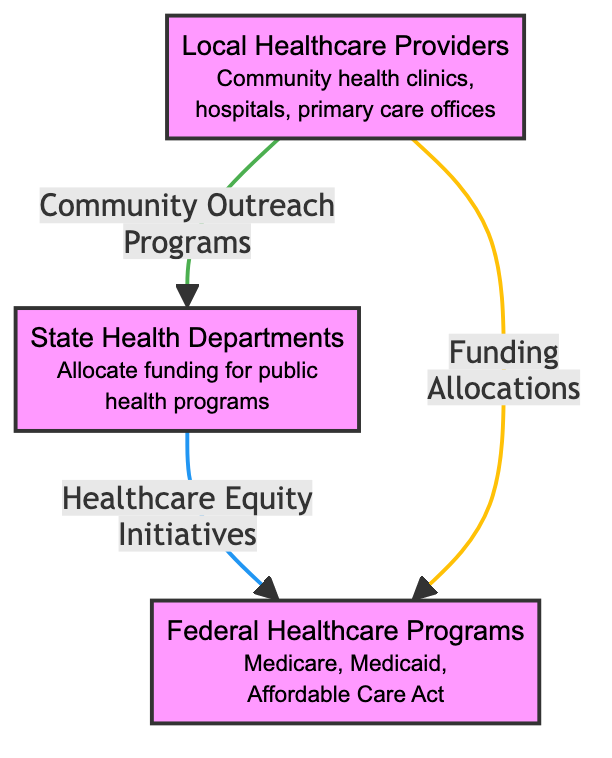What are the three nodes in the diagram? The diagram features three nodes: Local Healthcare Providers, State Health Departments, and Federal Healthcare Programs. Each node represents a specific group involved in the healthcare resource distribution process.
Answer: Local Healthcare Providers, State Health Departments, Federal Healthcare Programs How many edges are present in the diagram? The diagram contains three edges connecting the nodes. These edges illustrate the flow of information and funding between the different levels of healthcare resource allocation.
Answer: 3 What type of programs does the edge "Healthcare Equity Initiatives" represent? This edge indicates programs aimed at improving access and funding specifically for underserved populations. It highlights initiatives targeting equitable healthcare distribution.
Answer: Programs designed to improve access How does funding flow from State Health Departments to Federal Healthcare Programs? Funding flows from State Health Departments to Federal Healthcare Programs through the edge labeled "Healthcare Equity Initiatives." This shows how state-level efforts support federal-level programs.
Answer: Through Healthcare Equity Initiatives Which node directly receives funding allocations from Federal Healthcare Programs? The Local Healthcare Providers node directly receives funding allocations from the Federal Healthcare Programs, as indicated in the diagram.
Answer: Local Healthcare Providers What is the role of Community Outreach Programs in the diagram? Community Outreach Programs serve as partnerships that connect Local Healthcare Providers with organizations for distribution and education of healthcare resources. They play a crucial role in local initiatives.
Answer: Education and resource distribution What is the purpose of the edge "Funding Allocations"? The "Funding Allocations" edge illustrates the financial resources distributed to local healthcare providers based on demographic needs, linking higher-level funding sources to local healthcare entities.
Answer: Financial resources distribution Which node is the starting point for the flow of funding? The starting point for the flow of funding in the diagram is the Federal Healthcare Programs node, as it serves as a source of funding that is then allocated downwards to the state and local providers.
Answer: Federal Healthcare Programs What color represents Local Healthcare Providers in the diagram? Local Healthcare Providers are represented in a light purple color in the diagram, differentiating them visually from the other nodes.
Answer: Light purple 